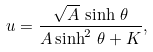Convert formula to latex. <formula><loc_0><loc_0><loc_500><loc_500>u = \frac { \sqrt { A } \, \sinh \, \theta } { A \sinh ^ { 2 } \, \theta + K } ,</formula> 